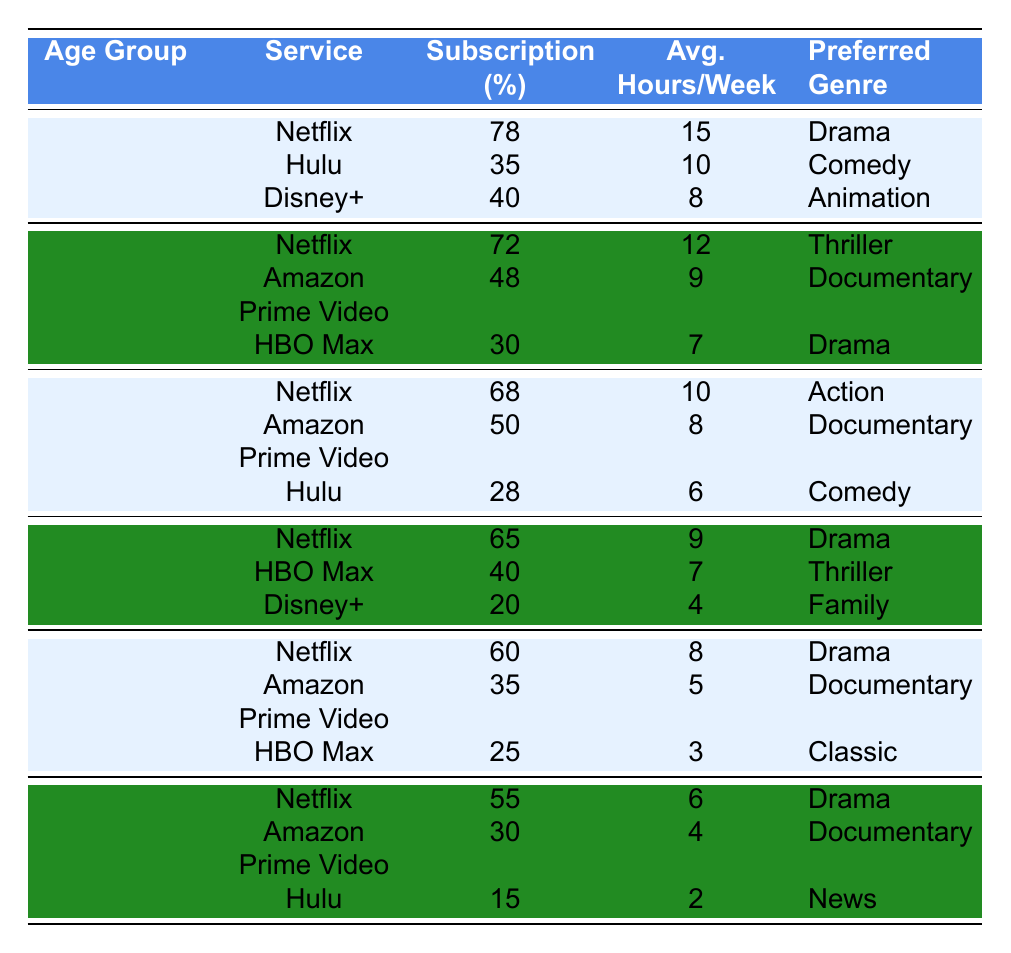What age group has the highest subscription percentage for Netflix? The 18-24 age group has the highest subscription percentage for Netflix at 78%.
Answer: 18-24 What is the preferred genre for the 25-34 age group using HBO Max? The preferred genre for the 25-34 age group using HBO Max is Drama.
Answer: Drama How many hours per week do 65+ year-olds spend on average watching Netflix? The 65+ year-old age group spends an average of 6 hours per week watching Netflix.
Answer: 6 hours Which streaming service has the lowest subscription percentage in the 45-54 age group? Disney+ has the lowest subscription percentage in the 45-54 age group at 20%.
Answer: Disney+ What is the average subscription percentage for the 35-44 age group across all services? The subscription percentages for the 35-44 age group are 68% (Netflix), 50% (Amazon Prime Video), and 28% (Hulu). The total is 146% and there are 3 services, so the average is 146/3 ≈ 48.67%.
Answer: 48.67% Is Hulu a preferred service for any age group? Yes, Hulu is preferred among the 18-24 age group with 35% subscription and the 35-44 age group with 28% subscription.
Answer: Yes How does the average hours per week differ between Netflix and Amazon Prime Video for the 55-64 age group? For the 55-64 age group, Netflix users average 8 hours per week while Amazon Prime Video users average 5 hours per week. The difference is 8 - 5 = 3 hours.
Answer: 3 hours Which age group has the highest subscription for Amazon Prime Video? The 25-34 age group has the highest subscription for Amazon Prime Video at 48%.
Answer: 25-34 Calculate the total subscription percentage for all services in the 18-24 age group. The subscription percentages for the 18-24 age group are 78% (Netflix), 35% (Hulu), and 40% (Disney+). The total is 78 + 35 + 40 = 153%.
Answer: 153% What is the preferred genre for the 55-64 age group using HBO Max? The preferred genre for the 55-64 age group using HBO Max is Classic.
Answer: Classic Is the subscription percentage for Netflix in the 65+ age group above or below 50%? The subscription percentage for Netflix in the 65+ age group is 55%, which is above 50%.
Answer: Above 50% 